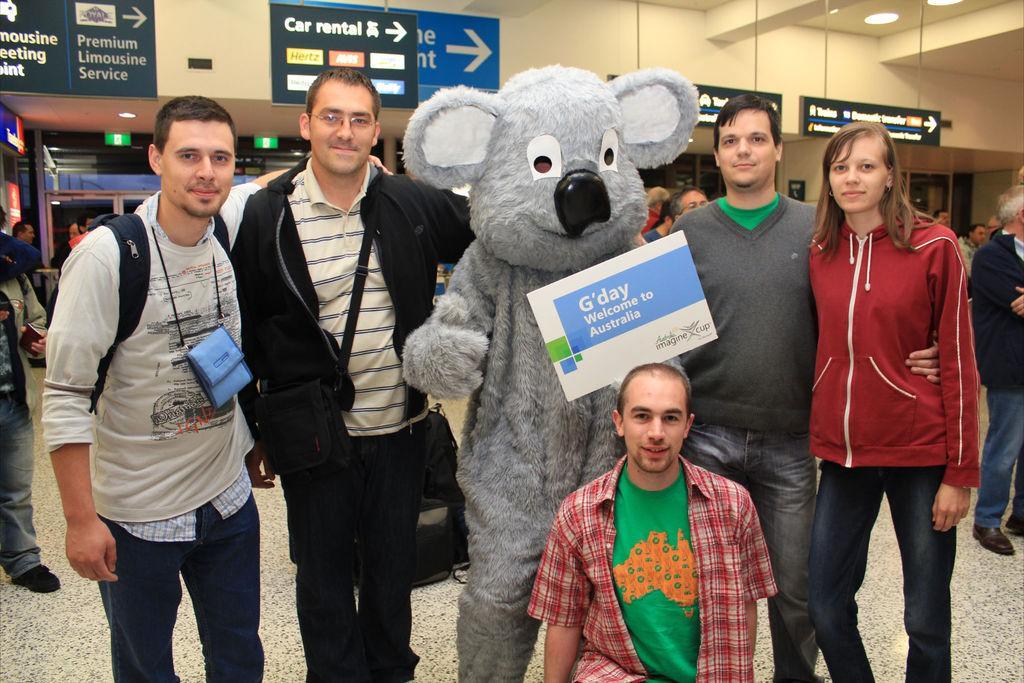In one or two sentences, can you explain what this image depicts? In this picture I can see few people standing and couple of them wore bags and I can see a human wore a mask and holding a board in the hand with text on it and I can see text on the few boards on the back and few people standing on the back and on the left and right side and I can see few lights to the ceiling and a man seated. 